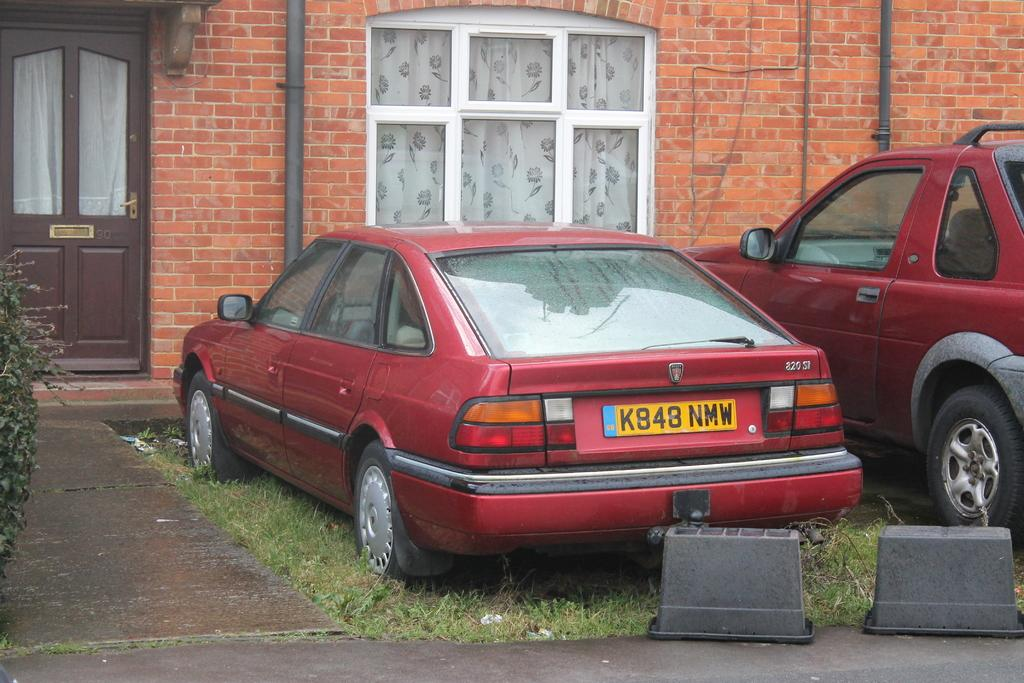What can be seen in the image related to transportation? There are vehicles in the image. Where is the door located in the image? The door is on the left side of the image. What can be seen in the background of the image? There is a window and a wall in the background of the image. How many passengers are visible in the image? There is no information about passengers in the image, as it only mentions vehicles, a door, a window, and a wall. 